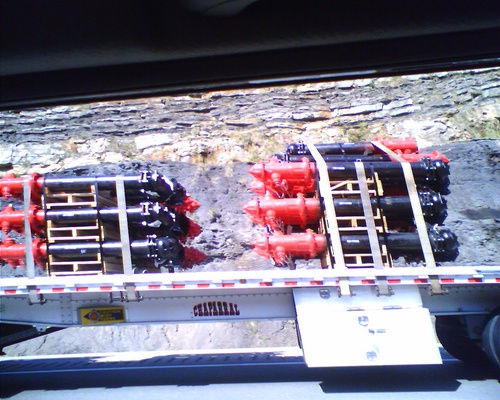Describe the objects in this image and their specific colors. I can see truck in black, white, gray, and darkgray tones, fire hydrant in black, lavender, navy, and gray tones, fire hydrant in black, lavender, navy, and darkgray tones, fire hydrant in black, pink, navy, and salmon tones, and fire hydrant in black, pink, salmon, red, and lightpink tones in this image. 